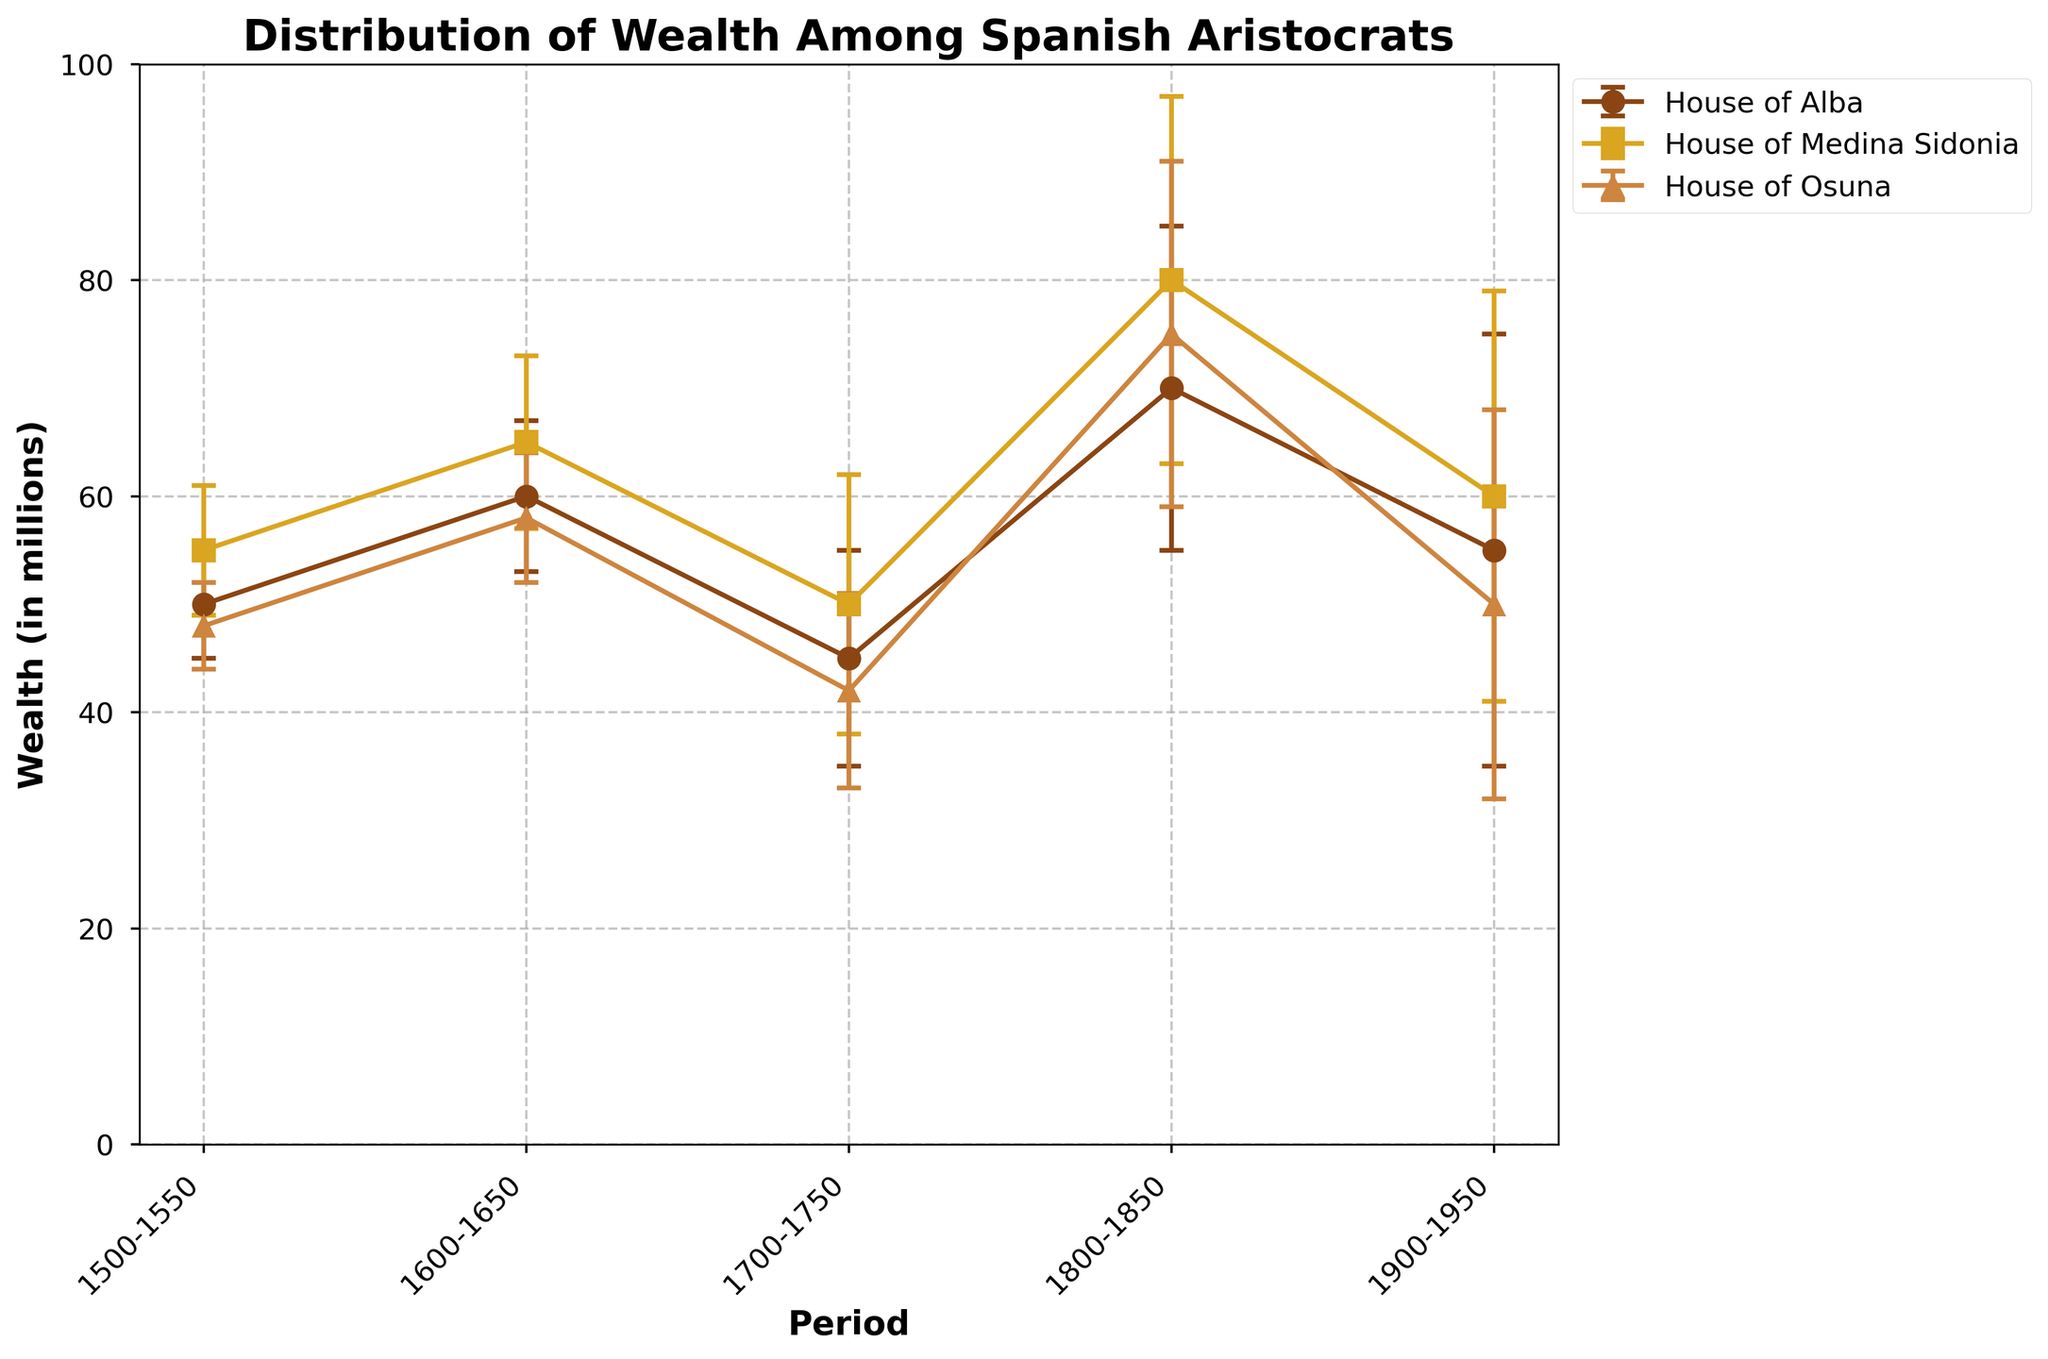What is the title of the graph? The title is displayed at the top of the figure. It gives a summary of what the figure is depicting.
Answer: Distribution of Wealth Among Spanish Aristocrats Does the House of Osuna have the highest wealth in any period? By examining each period, we can compare the wealth of the House of Osuna with the other houses. The House of Osuna has the highest wealth only in the period 1800-1850, where its wealth is 75 million, compared to 70 million for the House of Alba and 80 million for the House of Medina Sidonia.
Answer: No What was the wealth of the House of Alba in the period 1700-1750? Find the data point for the House of Alba in the period 1700-1750 along the x-axis and read the corresponding y-value.
Answer: 45 million Between which periods did the House of Medina Sidonia see a decrease in wealth? Track the wealth of the House of Medina Sidonia across each period. Identify where the wealth value goes from a higher to a lower value when moving from one period to the next.
Answer: 1600-1650 to 1700-1750 and 1800-1850 to 1900-1950 What is the range of error bars for the House of Alba in the period 1900-1950? Evaluate the error bar for the House of Alba in the period 1900-1950 by looking at the upper and lower extents y-values from the central data point. This is calculated as 55 million ± 20 million.
Answer: 35 million to 75 million Which house had the largest error in its wealth data in the period 1800-1850? Examine the error bars for all houses in the period 1800-1850. The House of Medina Sidonia has an error of 17 million, which is the largest among the three houses.
Answer: House of Medina Sidonia During which period did all three houses have the lowest wealth recorded? Calculate the lowest wealth point for each family across different periods and identify the period where all the values are at their minimum. In this case, it is the period 1700-1750 when the House of Alba had 45 million, House of Medina Sidonia had 50 million, and House of Osuna had 42 million.
Answer: 1700-1750 In which period did the wealth of the House of Alba increase the most compared to the previous period? Calculate the change in wealth for the House of Alba between each period by subtracting the previous period's wealth value from the current period's wealth value. The largest increase is from the period 1700-1750 (45 million) to 1800-1850 (70 million).
Answer: 1700-1750 to 1800-1850 What is the average wealth of all the houses in the period 1600-1650? Sum the wealth values of all three houses in the period 1600-1650 and then divide by the number of houses (3). The calculation is (60 million + 65 million + 58 million) / 3 = 61 million.
Answer: 61 million 